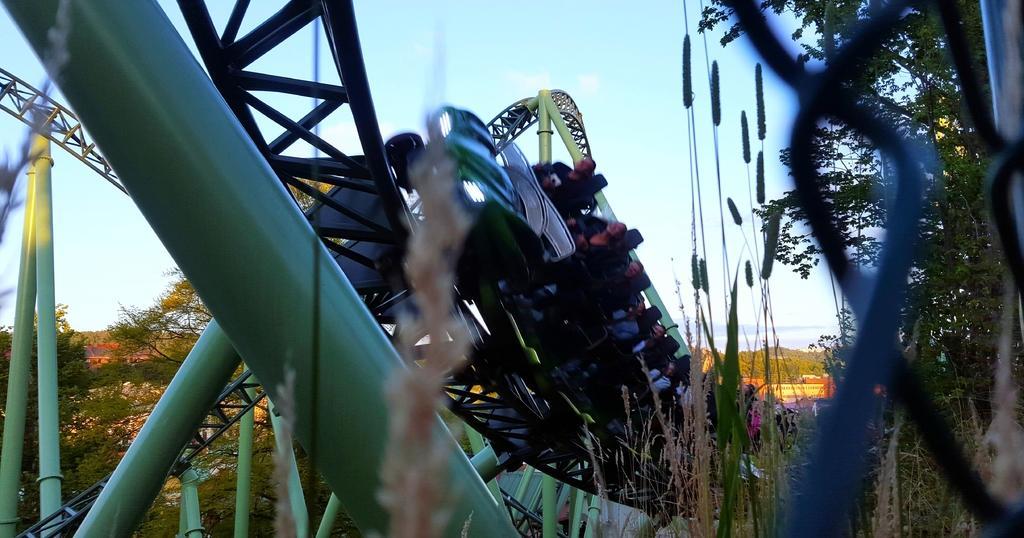Could you give a brief overview of what you see in this image? In this image in the front there is a roller coaster along with the tracks. On the right side there are trees. In the background there are trees and plants. 